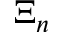<formula> <loc_0><loc_0><loc_500><loc_500>\Xi _ { n }</formula> 